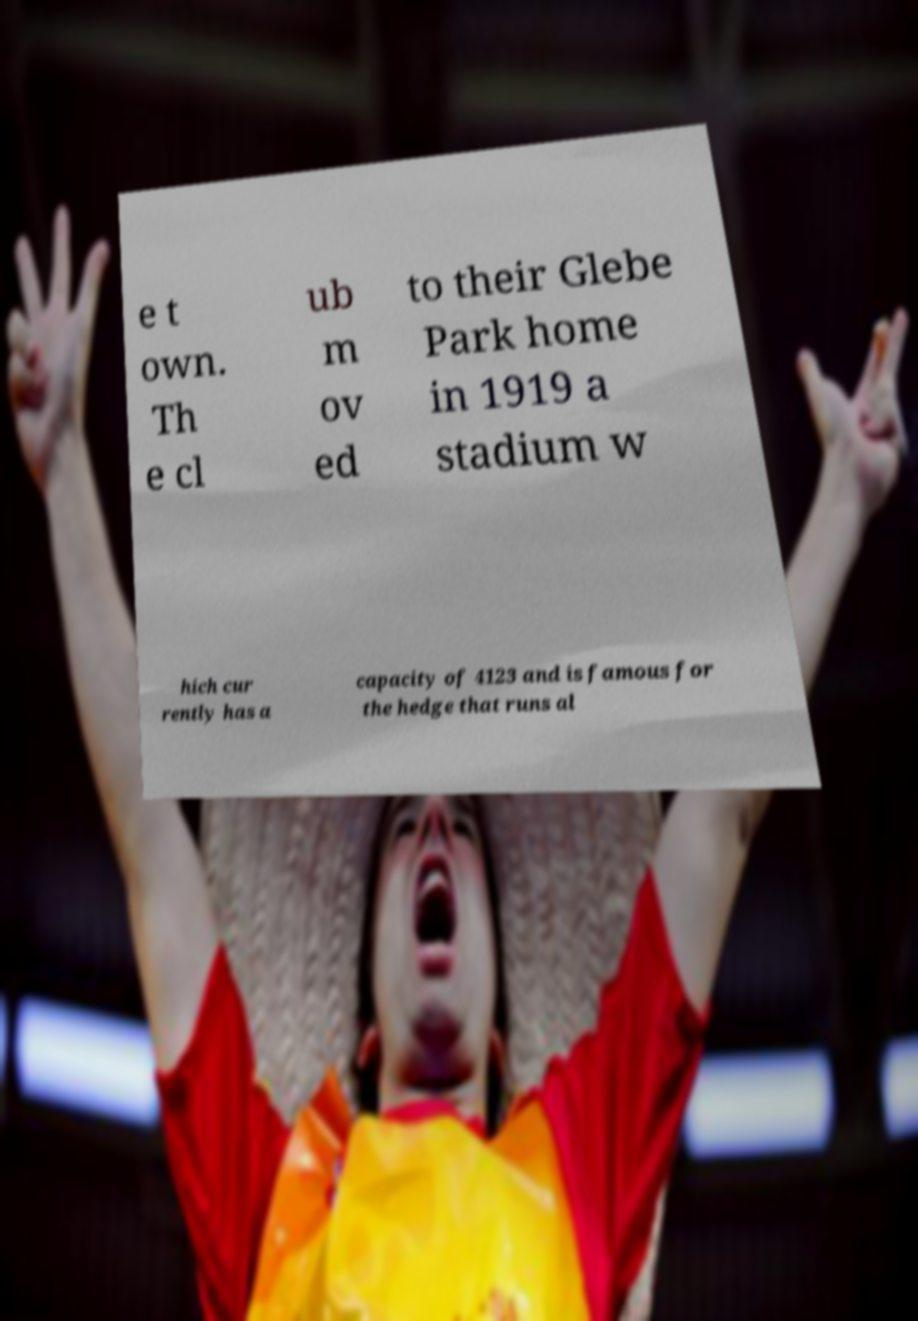Can you read and provide the text displayed in the image?This photo seems to have some interesting text. Can you extract and type it out for me? e t own. Th e cl ub m ov ed to their Glebe Park home in 1919 a stadium w hich cur rently has a capacity of 4123 and is famous for the hedge that runs al 